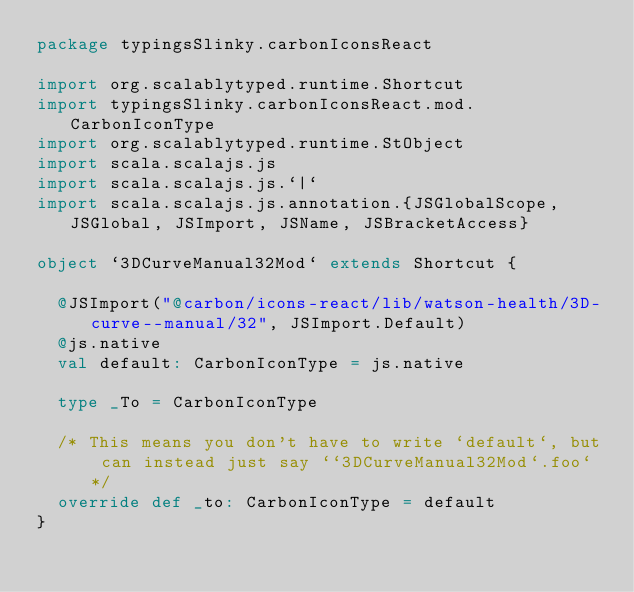Convert code to text. <code><loc_0><loc_0><loc_500><loc_500><_Scala_>package typingsSlinky.carbonIconsReact

import org.scalablytyped.runtime.Shortcut
import typingsSlinky.carbonIconsReact.mod.CarbonIconType
import org.scalablytyped.runtime.StObject
import scala.scalajs.js
import scala.scalajs.js.`|`
import scala.scalajs.js.annotation.{JSGlobalScope, JSGlobal, JSImport, JSName, JSBracketAccess}

object `3DCurveManual32Mod` extends Shortcut {
  
  @JSImport("@carbon/icons-react/lib/watson-health/3D-curve--manual/32", JSImport.Default)
  @js.native
  val default: CarbonIconType = js.native
  
  type _To = CarbonIconType
  
  /* This means you don't have to write `default`, but can instead just say ``3DCurveManual32Mod`.foo` */
  override def _to: CarbonIconType = default
}
</code> 